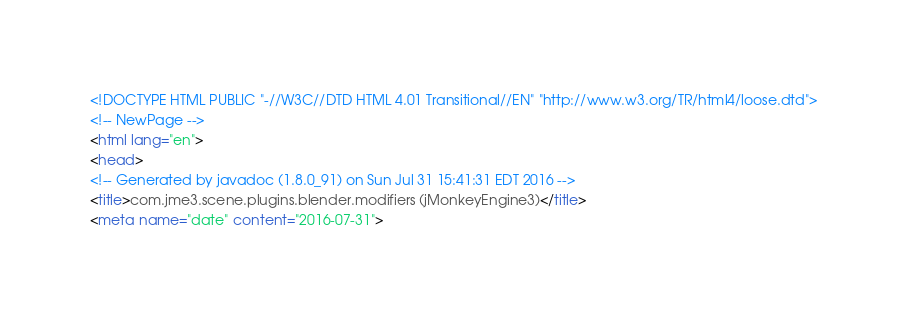Convert code to text. <code><loc_0><loc_0><loc_500><loc_500><_HTML_><!DOCTYPE HTML PUBLIC "-//W3C//DTD HTML 4.01 Transitional//EN" "http://www.w3.org/TR/html4/loose.dtd">
<!-- NewPage -->
<html lang="en">
<head>
<!-- Generated by javadoc (1.8.0_91) on Sun Jul 31 15:41:31 EDT 2016 -->
<title>com.jme3.scene.plugins.blender.modifiers (jMonkeyEngine3)</title>
<meta name="date" content="2016-07-31"></code> 